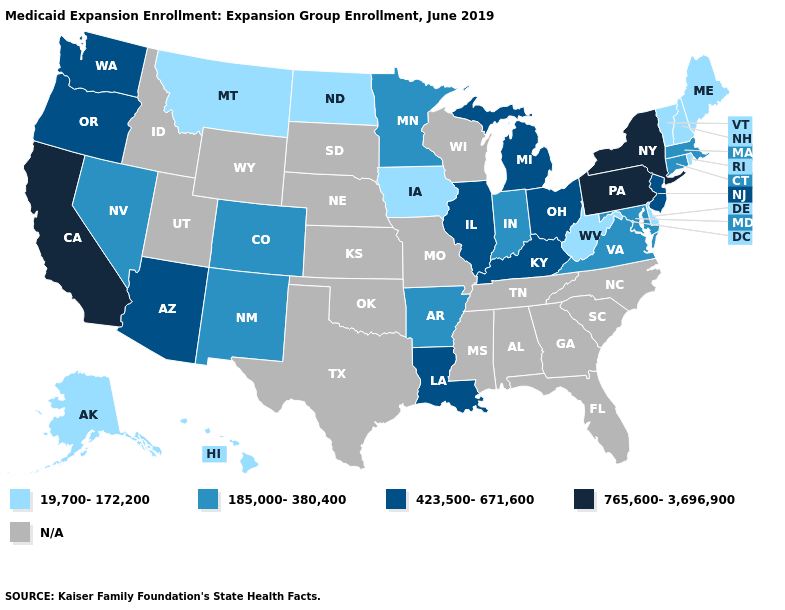Among the states that border Nebraska , which have the highest value?
Short answer required. Colorado. What is the value of Minnesota?
Quick response, please. 185,000-380,400. Among the states that border Washington , which have the lowest value?
Short answer required. Oregon. Does Montana have the lowest value in the USA?
Short answer required. Yes. Name the states that have a value in the range 19,700-172,200?
Keep it brief. Alaska, Delaware, Hawaii, Iowa, Maine, Montana, New Hampshire, North Dakota, Rhode Island, Vermont, West Virginia. Among the states that border North Dakota , which have the lowest value?
Concise answer only. Montana. Name the states that have a value in the range 19,700-172,200?
Write a very short answer. Alaska, Delaware, Hawaii, Iowa, Maine, Montana, New Hampshire, North Dakota, Rhode Island, Vermont, West Virginia. Does Iowa have the highest value in the USA?
Quick response, please. No. Does Michigan have the lowest value in the USA?
Write a very short answer. No. Is the legend a continuous bar?
Write a very short answer. No. Which states have the lowest value in the Northeast?
Give a very brief answer. Maine, New Hampshire, Rhode Island, Vermont. Does New York have the highest value in the Northeast?
Keep it brief. Yes. Which states have the lowest value in the MidWest?
Give a very brief answer. Iowa, North Dakota. Which states have the highest value in the USA?
Keep it brief. California, New York, Pennsylvania. 